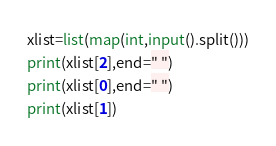<code> <loc_0><loc_0><loc_500><loc_500><_Python_>xlist=list(map(int,input().split()))
print(xlist[2],end=" ")
print(xlist[0],end=" ")
print(xlist[1])
</code> 